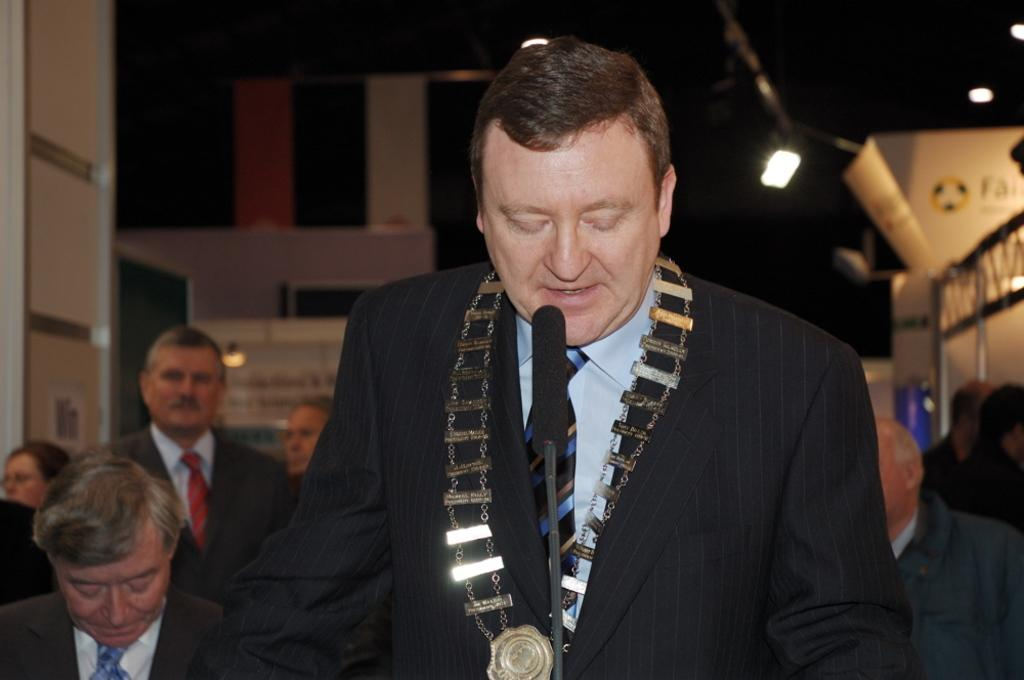What is the person in the image wearing? The person in the image is wearing a suit. What is the person in the suit doing in the image? The person is talking in front of a microphone. What can be seen in the background of the image? There is a group of people, rods, banners, and lights visible in the background of the image. What month is it in the image? The month cannot be determined from the image, as there is no information about the date or time of year. 